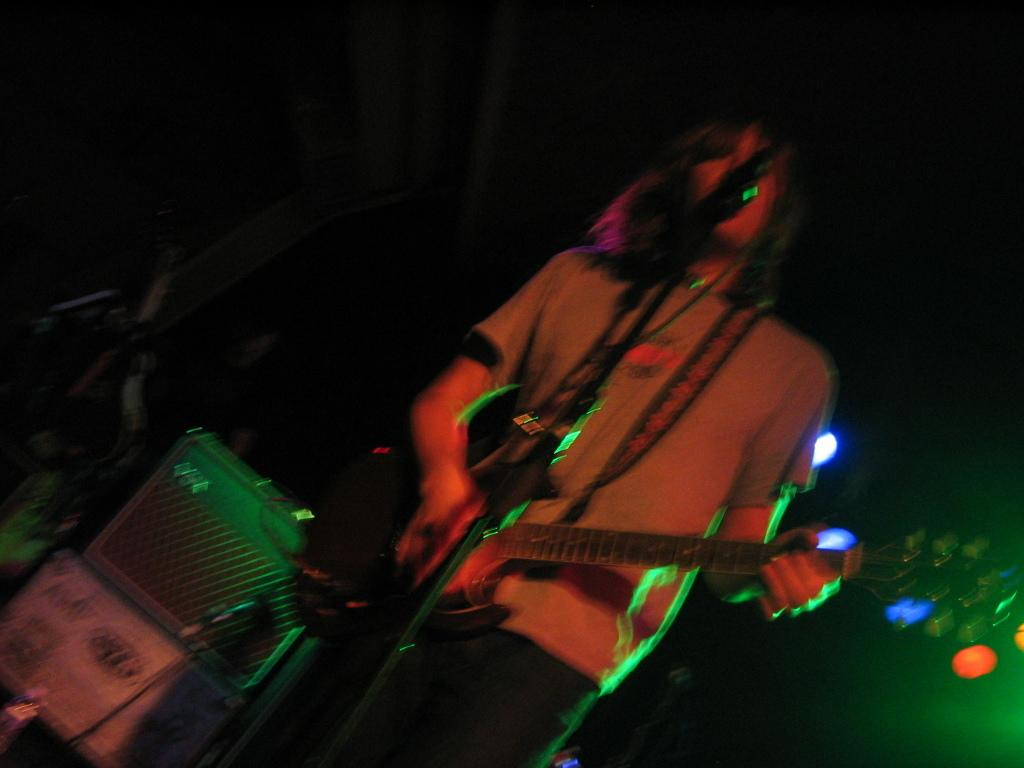What is the man in the image doing? The man is playing a guitar. How is the man positioned in the image? The man is standing. What objects can be seen behind the man? There are boxes behind the man. What can be observed about the lighting in the image? There is light in the image. What type of account does the frog have in the image? There is no frog present in the image, so it is not possible to determine if it has an account or not. 